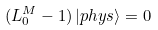Convert formula to latex. <formula><loc_0><loc_0><loc_500><loc_500>( L _ { 0 } ^ { M } - 1 ) \, | p h y s \rangle = 0</formula> 